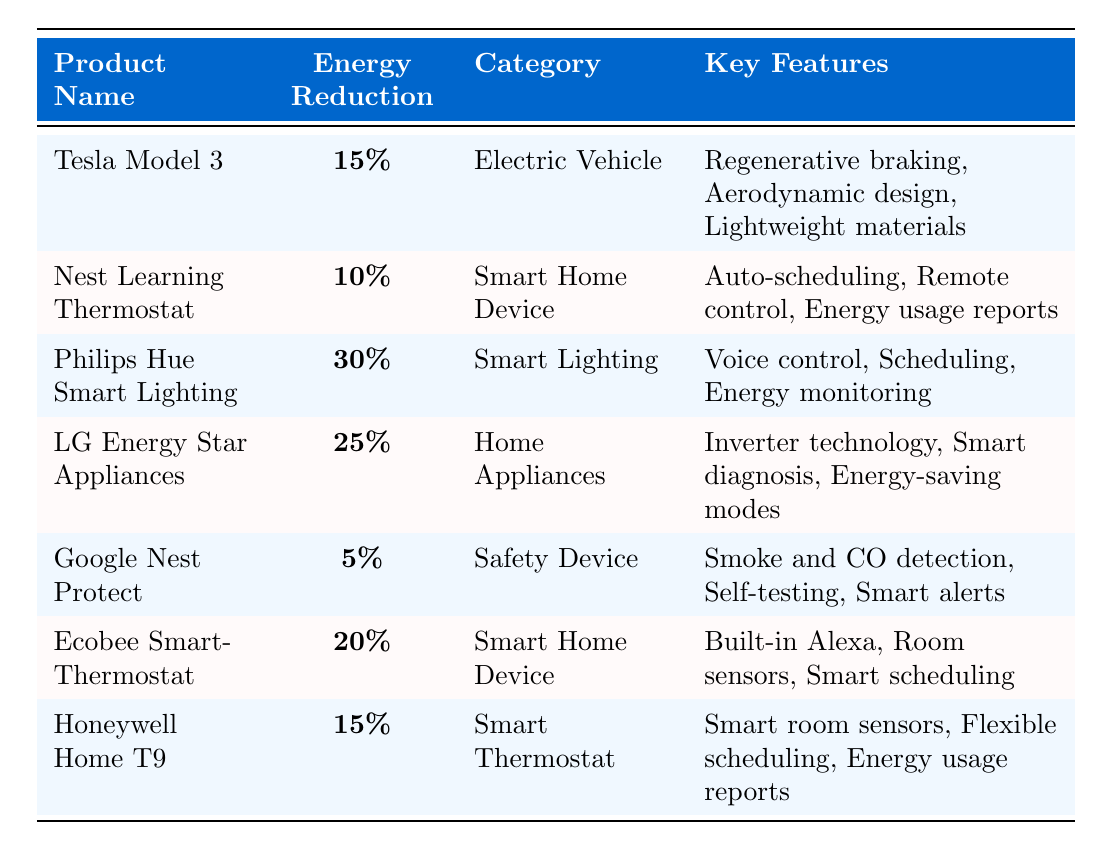What is the highest energy consumption reduction metric recorded in the table? By reviewing the table, the highest value is found under the product "Philips Hue Smart Lighting," which shows a reduction metric of 30%.
Answer: 30% Which product has the lowest energy consumption reduction, and what is that percentage? The product with the lowest energy consumption reduction is "Google Nest Protect," which has a reduction metric of 5%.
Answer: 5% How many products have an energy consumption reduction of 15%? There are two products listed with a reduction of 15%: "Tesla Model 3" and "Honeywell Home T9."
Answer: 2 What is the average energy consumption reduction across all listed products? To find the average, sum up the percentages: 15 + 10 + 30 + 25 + 5 + 20 + 15 = 120. There are 7 products, so the average is 120 / 7 = approximately 17.14%.
Answer: 17.14% Is there a smart home device that has a higher energy reduction than 20%? Yes, "Philips Hue Smart Lighting" has an energy reduction of 30%, which is higher than 20%.
Answer: Yes What is the difference in energy reduction metrics between the product with the highest and the lowest values? The highest energy reduction is 30% (Philips Hue Smart Lighting) and the lowest is 5% (Google Nest Protect). The difference is 30% - 5% = 25%.
Answer: 25% Which category has the most products represented in this table? There are four products categorized as "Smart Home Device" including "Nest Learning Thermostat" and "Ecobee SmartThermostat," making this the most represented category.
Answer: Smart Home Device Are there any devices that achieve more than 20% energy reduction? Yes, "Philips Hue Smart Lighting" and "LG Energy Star Appliances" both exceed 20% energy reduction.
Answer: Yes What key feature is shared between "LG Energy Star Appliances" and "Honeywell Home T9"? Both products include energy usage reports as a key feature.
Answer: Energy usage reports How do the energy reductions of smart home devices compare to electric vehicles? The "Nest Learning Thermostat" (10%) and "Ecobee SmartThermostat" (20%) average to 15%, while "Tesla Model 3" (15%) matches this average exactly. Therefore, it's a direct comparison of equal average reductions (15% each) for both categories.
Answer: Equal comparison 